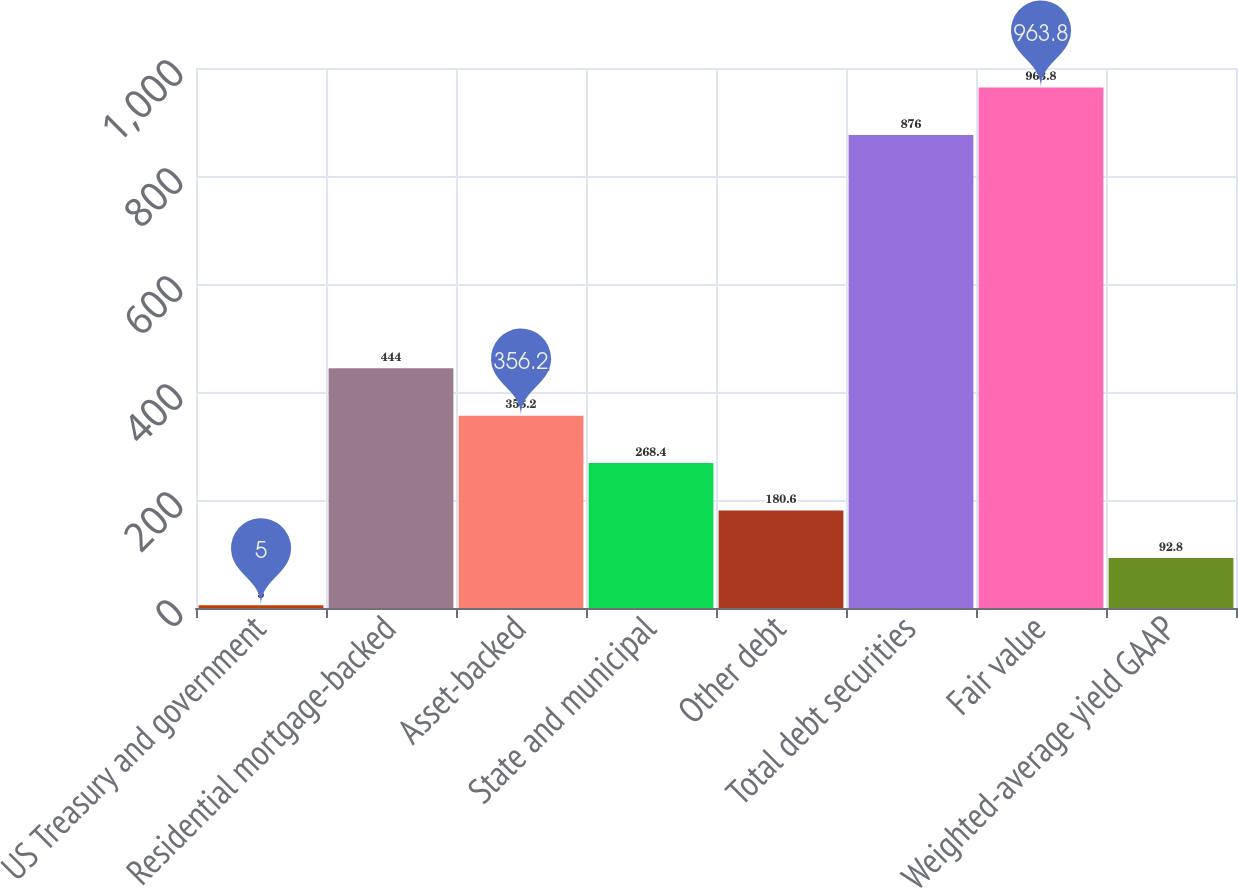Convert chart. <chart><loc_0><loc_0><loc_500><loc_500><bar_chart><fcel>US Treasury and government<fcel>Residential mortgage-backed<fcel>Asset-backed<fcel>State and municipal<fcel>Other debt<fcel>Total debt securities<fcel>Fair value<fcel>Weighted-average yield GAAP<nl><fcel>5<fcel>444<fcel>356.2<fcel>268.4<fcel>180.6<fcel>876<fcel>963.8<fcel>92.8<nl></chart> 